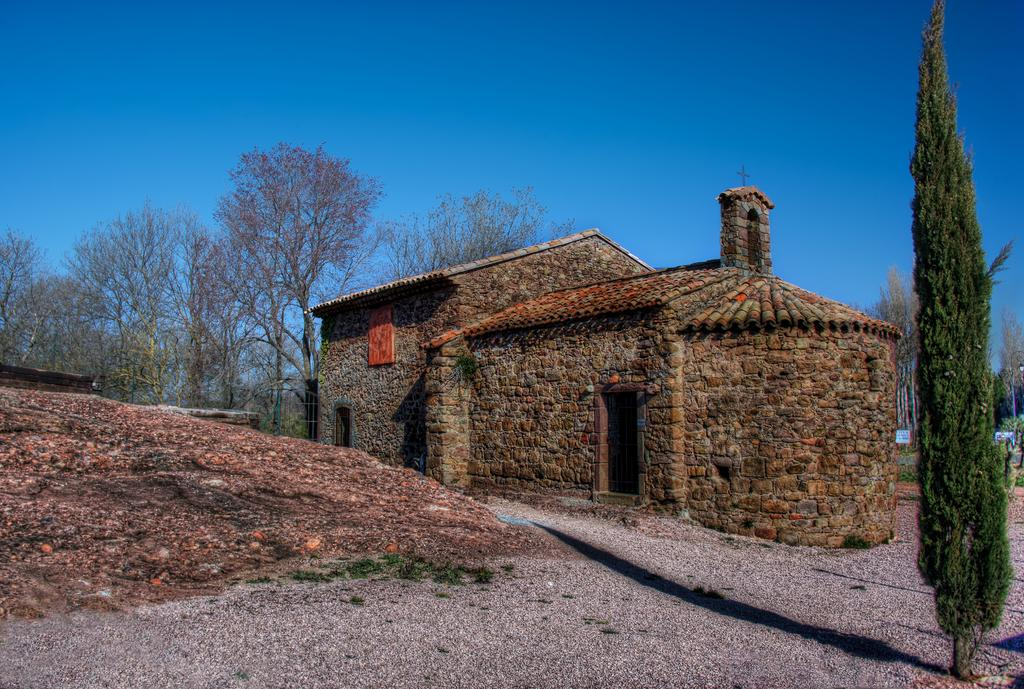What can be seen in the center of the image? The sky is visible in the center of the image. What type of natural elements are present in the image? There are trees in the image. Are there any man-made structures visible? Yes, there is at least one building in the image. Can you describe any other objects in the image? There are a few other objects in the image, but their specific details are not mentioned in the provided facts. What type of coal is being used to jump over the hammer in the image? There is no coal, hammer, or jumping activity present in the image. 